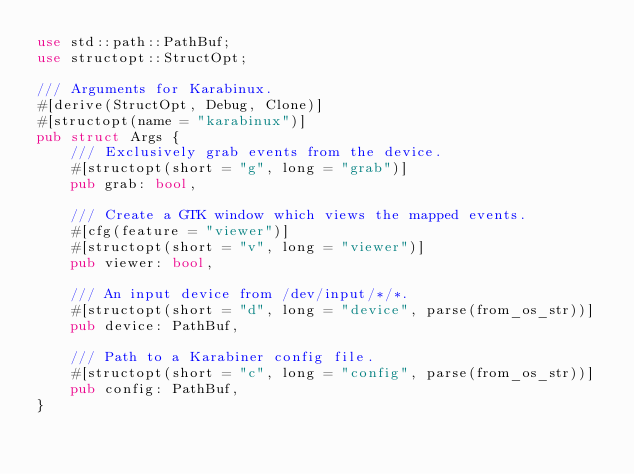<code> <loc_0><loc_0><loc_500><loc_500><_Rust_>use std::path::PathBuf;
use structopt::StructOpt;

/// Arguments for Karabinux.
#[derive(StructOpt, Debug, Clone)]
#[structopt(name = "karabinux")]
pub struct Args {
    /// Exclusively grab events from the device.
    #[structopt(short = "g", long = "grab")]
    pub grab: bool,

    /// Create a GTK window which views the mapped events.
    #[cfg(feature = "viewer")]
    #[structopt(short = "v", long = "viewer")]
    pub viewer: bool,

    /// An input device from /dev/input/*/*.
    #[structopt(short = "d", long = "device", parse(from_os_str))]
    pub device: PathBuf,

    /// Path to a Karabiner config file.
    #[structopt(short = "c", long = "config", parse(from_os_str))]
    pub config: PathBuf,
}
</code> 